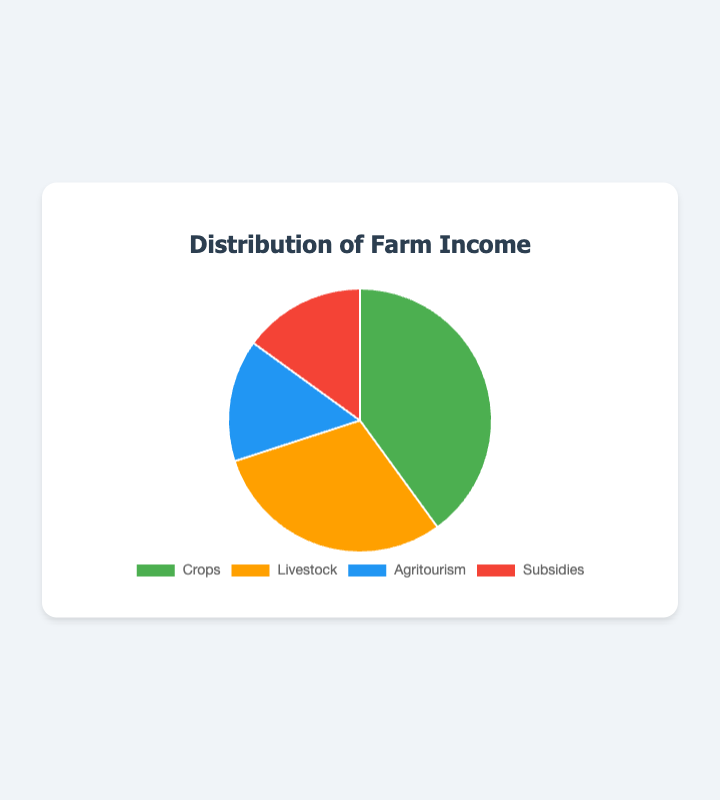What is the largest revenue stream for the farm? From the pie chart, the largest segment represents the "Crops" revenue stream, which has a percentage of 40%.
Answer: Crops Which revenue streams each contribute 15% of the farm income? The legend and the segments show that "Agritourism" and "Subsidies" each contribute 15% to the farm income.
Answer: Agritourism and Subsidies How much more does Crops contribute to the farm income compared to Livestock? The pie chart shows that Crops contribute 40% and Livestock contributes 30%. Subtracting these percentages gives 40% - 30% = 10%.
Answer: 10% What percentage of the farm income comes from non-crop sources? Adding the percentages of Livestock, Agritourism, and Subsidies, we get 30% + 15% + 15% = 60%.
Answer: 60% Which revenue stream has the smallest contribution to the farm income? From the pie chart, Agritourism and Subsidies both have the smallest contributions, each at 15%.
Answer: Agritourism and Subsidies How much combined income is generated from Crops and Livestock? Adding the percentages of Crops and Livestock, we get 40% + 30% = 70%.
Answer: 70% If the total farm income is $100,000, how much money comes from Agritourism? Agritourism is 15% of the farm income. Calculating 15% of $100,000 gives 0.15 * $100,000 = $15,000.
Answer: $15,000 Which color represents Livestock in the pie chart? The segment labeled "Livestock" is colored orange.
Answer: Orange What is the average percentage of income from Agritourism and Subsidies? The percentages for both Agritourism and Subsidies are each 15%. The average is calculated as (15% + 15%) / 2 = 15%.
Answer: 15% Between Livestock and Agritourism, which contributes more to the farm income, and by how much? The pie chart shows Livestock contributes 30% and Agritourism contributes 15%. The difference is 30% - 15% = 15%.
Answer: Livestock by 15% 